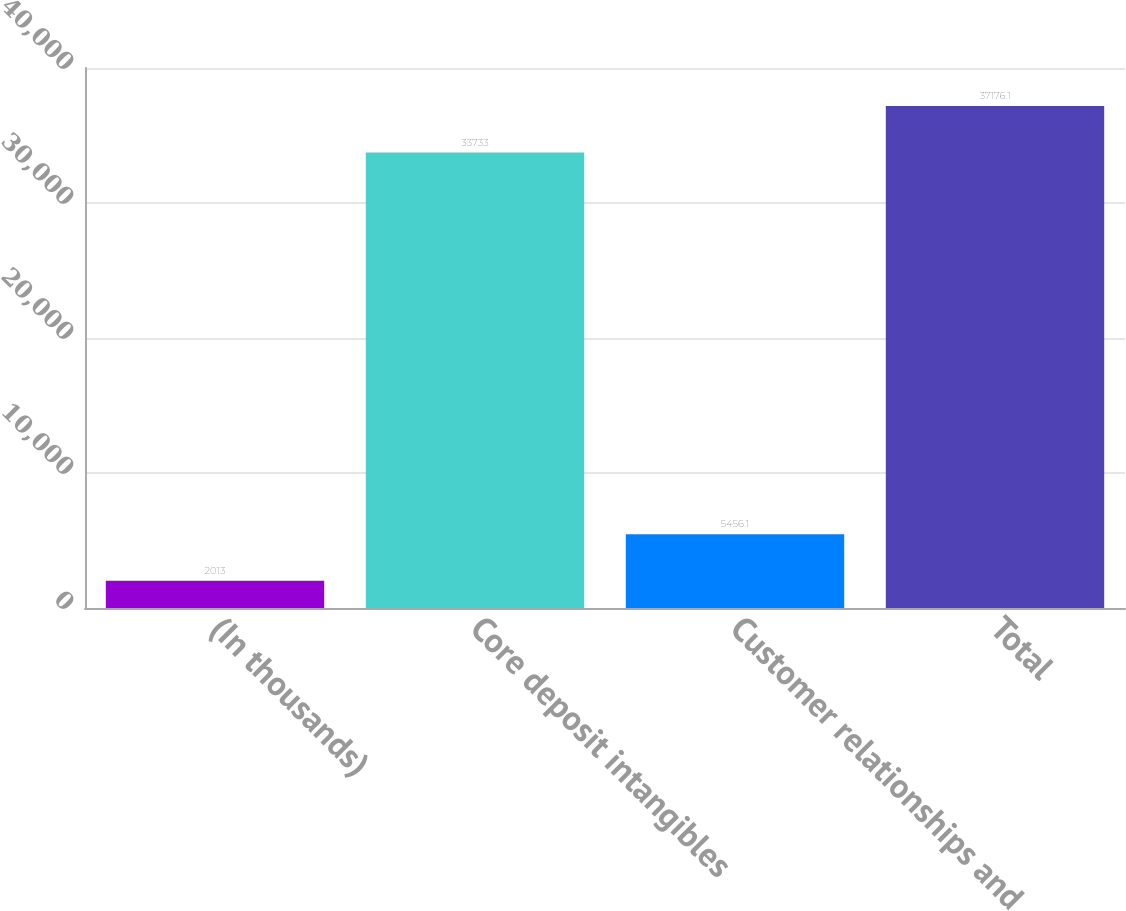Convert chart. <chart><loc_0><loc_0><loc_500><loc_500><bar_chart><fcel>(In thousands)<fcel>Core deposit intangibles<fcel>Customer relationships and<fcel>Total<nl><fcel>2013<fcel>33733<fcel>5456.1<fcel>37176.1<nl></chart> 